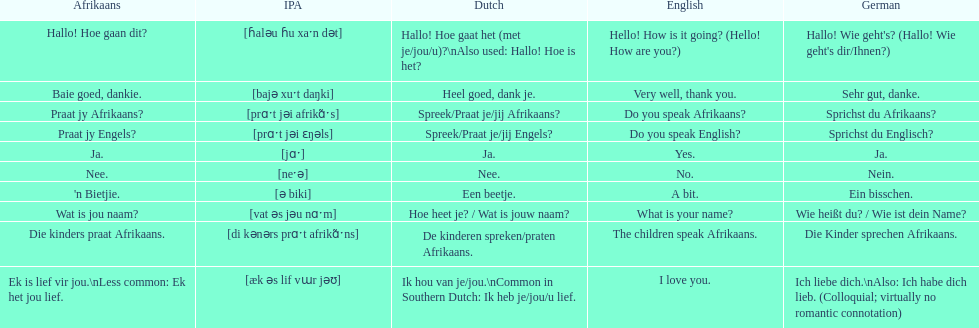How do you say "do you speak afrikaans?" in afrikaans? Praat jy Afrikaans?. 